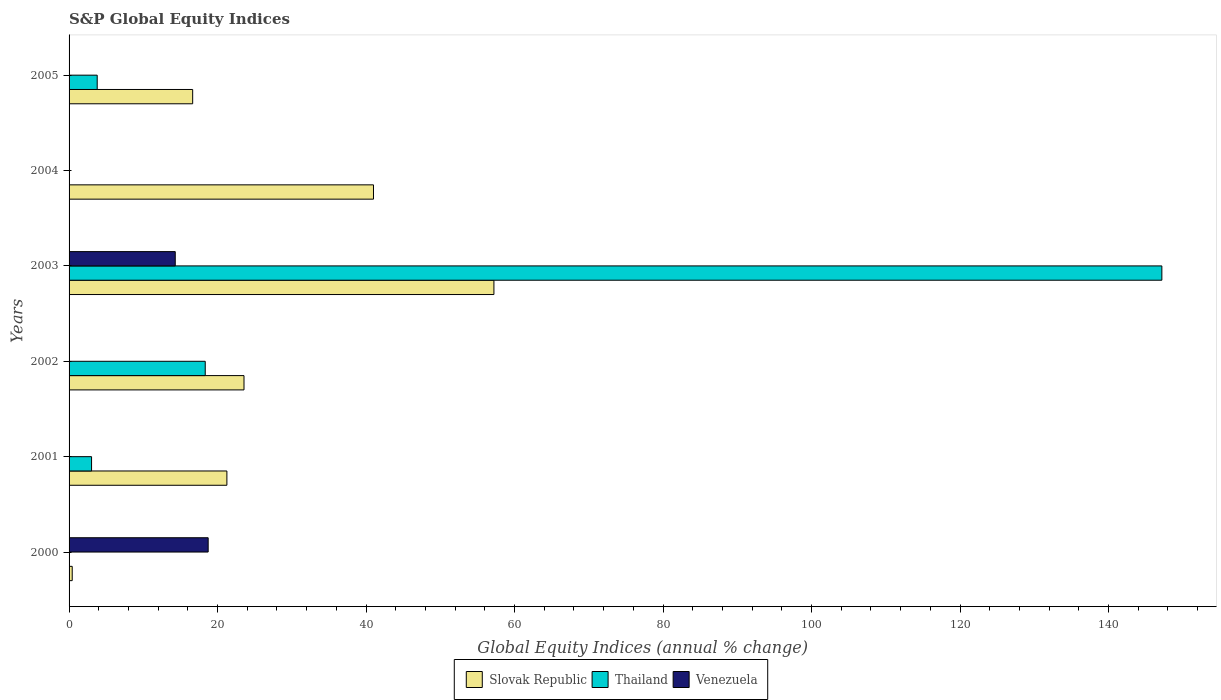How many different coloured bars are there?
Provide a short and direct response. 3. How many bars are there on the 1st tick from the top?
Offer a terse response. 2. How many bars are there on the 4th tick from the bottom?
Provide a succinct answer. 3. What is the label of the 6th group of bars from the top?
Your answer should be compact. 2000. What is the global equity indices in Thailand in 2000?
Provide a short and direct response. 0. Across all years, what is the maximum global equity indices in Venezuela?
Your answer should be very brief. 18.74. What is the total global equity indices in Slovak Republic in the graph?
Offer a very short reply. 160.11. What is the difference between the global equity indices in Slovak Republic in 2004 and that in 2005?
Give a very brief answer. 24.35. What is the difference between the global equity indices in Venezuela in 2003 and the global equity indices in Slovak Republic in 2002?
Your response must be concise. -9.26. What is the average global equity indices in Thailand per year?
Make the answer very short. 28.72. In the year 2000, what is the difference between the global equity indices in Venezuela and global equity indices in Slovak Republic?
Your answer should be compact. 18.31. In how many years, is the global equity indices in Slovak Republic greater than 120 %?
Ensure brevity in your answer.  0. What is the difference between the highest and the second highest global equity indices in Slovak Republic?
Provide a succinct answer. 16.22. What is the difference between the highest and the lowest global equity indices in Thailand?
Keep it short and to the point. 147.18. In how many years, is the global equity indices in Venezuela greater than the average global equity indices in Venezuela taken over all years?
Offer a terse response. 2. How many bars are there?
Offer a terse response. 12. Are all the bars in the graph horizontal?
Your answer should be very brief. Yes. How many years are there in the graph?
Your response must be concise. 6. What is the difference between two consecutive major ticks on the X-axis?
Your response must be concise. 20. Does the graph contain any zero values?
Offer a very short reply. Yes. Where does the legend appear in the graph?
Your answer should be very brief. Bottom center. How are the legend labels stacked?
Keep it short and to the point. Horizontal. What is the title of the graph?
Offer a terse response. S&P Global Equity Indices. What is the label or title of the X-axis?
Offer a terse response. Global Equity Indices (annual % change). What is the label or title of the Y-axis?
Offer a terse response. Years. What is the Global Equity Indices (annual % change) in Slovak Republic in 2000?
Make the answer very short. 0.42. What is the Global Equity Indices (annual % change) of Thailand in 2000?
Offer a very short reply. 0. What is the Global Equity Indices (annual % change) of Venezuela in 2000?
Your answer should be very brief. 18.74. What is the Global Equity Indices (annual % change) of Slovak Republic in 2001?
Offer a very short reply. 21.26. What is the Global Equity Indices (annual % change) in Thailand in 2001?
Make the answer very short. 3.03. What is the Global Equity Indices (annual % change) of Venezuela in 2001?
Offer a terse response. 0. What is the Global Equity Indices (annual % change) of Slovak Republic in 2002?
Make the answer very short. 23.56. What is the Global Equity Indices (annual % change) of Thailand in 2002?
Your answer should be very brief. 18.34. What is the Global Equity Indices (annual % change) in Slovak Republic in 2003?
Offer a terse response. 57.22. What is the Global Equity Indices (annual % change) in Thailand in 2003?
Your answer should be very brief. 147.18. What is the Global Equity Indices (annual % change) of Venezuela in 2003?
Ensure brevity in your answer.  14.3. What is the Global Equity Indices (annual % change) in Slovak Republic in 2004?
Offer a very short reply. 41. What is the Global Equity Indices (annual % change) in Thailand in 2004?
Give a very brief answer. 0. What is the Global Equity Indices (annual % change) in Slovak Republic in 2005?
Your response must be concise. 16.65. What is the Global Equity Indices (annual % change) in Thailand in 2005?
Your response must be concise. 3.79. Across all years, what is the maximum Global Equity Indices (annual % change) in Slovak Republic?
Keep it short and to the point. 57.22. Across all years, what is the maximum Global Equity Indices (annual % change) of Thailand?
Make the answer very short. 147.18. Across all years, what is the maximum Global Equity Indices (annual % change) in Venezuela?
Your answer should be very brief. 18.74. Across all years, what is the minimum Global Equity Indices (annual % change) of Slovak Republic?
Provide a succinct answer. 0.42. Across all years, what is the minimum Global Equity Indices (annual % change) in Venezuela?
Keep it short and to the point. 0. What is the total Global Equity Indices (annual % change) of Slovak Republic in the graph?
Your response must be concise. 160.11. What is the total Global Equity Indices (annual % change) of Thailand in the graph?
Ensure brevity in your answer.  172.34. What is the total Global Equity Indices (annual % change) in Venezuela in the graph?
Provide a short and direct response. 33.04. What is the difference between the Global Equity Indices (annual % change) in Slovak Republic in 2000 and that in 2001?
Give a very brief answer. -20.83. What is the difference between the Global Equity Indices (annual % change) in Slovak Republic in 2000 and that in 2002?
Ensure brevity in your answer.  -23.14. What is the difference between the Global Equity Indices (annual % change) in Slovak Republic in 2000 and that in 2003?
Your response must be concise. -56.8. What is the difference between the Global Equity Indices (annual % change) of Venezuela in 2000 and that in 2003?
Keep it short and to the point. 4.44. What is the difference between the Global Equity Indices (annual % change) in Slovak Republic in 2000 and that in 2004?
Make the answer very short. -40.58. What is the difference between the Global Equity Indices (annual % change) in Slovak Republic in 2000 and that in 2005?
Make the answer very short. -16.22. What is the difference between the Global Equity Indices (annual % change) of Slovak Republic in 2001 and that in 2002?
Your answer should be very brief. -2.3. What is the difference between the Global Equity Indices (annual % change) in Thailand in 2001 and that in 2002?
Your response must be concise. -15.31. What is the difference between the Global Equity Indices (annual % change) of Slovak Republic in 2001 and that in 2003?
Provide a succinct answer. -35.96. What is the difference between the Global Equity Indices (annual % change) in Thailand in 2001 and that in 2003?
Provide a short and direct response. -144.15. What is the difference between the Global Equity Indices (annual % change) of Slovak Republic in 2001 and that in 2004?
Your answer should be very brief. -19.74. What is the difference between the Global Equity Indices (annual % change) in Slovak Republic in 2001 and that in 2005?
Offer a terse response. 4.61. What is the difference between the Global Equity Indices (annual % change) of Thailand in 2001 and that in 2005?
Make the answer very short. -0.76. What is the difference between the Global Equity Indices (annual % change) in Slovak Republic in 2002 and that in 2003?
Offer a very short reply. -33.66. What is the difference between the Global Equity Indices (annual % change) of Thailand in 2002 and that in 2003?
Give a very brief answer. -128.84. What is the difference between the Global Equity Indices (annual % change) of Slovak Republic in 2002 and that in 2004?
Give a very brief answer. -17.44. What is the difference between the Global Equity Indices (annual % change) in Slovak Republic in 2002 and that in 2005?
Give a very brief answer. 6.91. What is the difference between the Global Equity Indices (annual % change) in Thailand in 2002 and that in 2005?
Your answer should be compact. 14.55. What is the difference between the Global Equity Indices (annual % change) in Slovak Republic in 2003 and that in 2004?
Ensure brevity in your answer.  16.22. What is the difference between the Global Equity Indices (annual % change) of Slovak Republic in 2003 and that in 2005?
Make the answer very short. 40.57. What is the difference between the Global Equity Indices (annual % change) of Thailand in 2003 and that in 2005?
Provide a short and direct response. 143.39. What is the difference between the Global Equity Indices (annual % change) of Slovak Republic in 2004 and that in 2005?
Give a very brief answer. 24.35. What is the difference between the Global Equity Indices (annual % change) of Slovak Republic in 2000 and the Global Equity Indices (annual % change) of Thailand in 2001?
Offer a very short reply. -2.61. What is the difference between the Global Equity Indices (annual % change) in Slovak Republic in 2000 and the Global Equity Indices (annual % change) in Thailand in 2002?
Provide a succinct answer. -17.92. What is the difference between the Global Equity Indices (annual % change) in Slovak Republic in 2000 and the Global Equity Indices (annual % change) in Thailand in 2003?
Provide a short and direct response. -146.76. What is the difference between the Global Equity Indices (annual % change) in Slovak Republic in 2000 and the Global Equity Indices (annual % change) in Venezuela in 2003?
Make the answer very short. -13.88. What is the difference between the Global Equity Indices (annual % change) in Slovak Republic in 2000 and the Global Equity Indices (annual % change) in Thailand in 2005?
Make the answer very short. -3.37. What is the difference between the Global Equity Indices (annual % change) in Slovak Republic in 2001 and the Global Equity Indices (annual % change) in Thailand in 2002?
Keep it short and to the point. 2.92. What is the difference between the Global Equity Indices (annual % change) of Slovak Republic in 2001 and the Global Equity Indices (annual % change) of Thailand in 2003?
Make the answer very short. -125.92. What is the difference between the Global Equity Indices (annual % change) of Slovak Republic in 2001 and the Global Equity Indices (annual % change) of Venezuela in 2003?
Provide a short and direct response. 6.96. What is the difference between the Global Equity Indices (annual % change) in Thailand in 2001 and the Global Equity Indices (annual % change) in Venezuela in 2003?
Provide a short and direct response. -11.27. What is the difference between the Global Equity Indices (annual % change) of Slovak Republic in 2001 and the Global Equity Indices (annual % change) of Thailand in 2005?
Provide a short and direct response. 17.47. What is the difference between the Global Equity Indices (annual % change) in Slovak Republic in 2002 and the Global Equity Indices (annual % change) in Thailand in 2003?
Your answer should be compact. -123.62. What is the difference between the Global Equity Indices (annual % change) of Slovak Republic in 2002 and the Global Equity Indices (annual % change) of Venezuela in 2003?
Ensure brevity in your answer.  9.26. What is the difference between the Global Equity Indices (annual % change) in Thailand in 2002 and the Global Equity Indices (annual % change) in Venezuela in 2003?
Your response must be concise. 4.04. What is the difference between the Global Equity Indices (annual % change) in Slovak Republic in 2002 and the Global Equity Indices (annual % change) in Thailand in 2005?
Make the answer very short. 19.77. What is the difference between the Global Equity Indices (annual % change) of Slovak Republic in 2003 and the Global Equity Indices (annual % change) of Thailand in 2005?
Offer a very short reply. 53.43. What is the difference between the Global Equity Indices (annual % change) in Slovak Republic in 2004 and the Global Equity Indices (annual % change) in Thailand in 2005?
Offer a terse response. 37.21. What is the average Global Equity Indices (annual % change) in Slovak Republic per year?
Make the answer very short. 26.68. What is the average Global Equity Indices (annual % change) of Thailand per year?
Your answer should be very brief. 28.72. What is the average Global Equity Indices (annual % change) of Venezuela per year?
Make the answer very short. 5.51. In the year 2000, what is the difference between the Global Equity Indices (annual % change) in Slovak Republic and Global Equity Indices (annual % change) in Venezuela?
Your response must be concise. -18.31. In the year 2001, what is the difference between the Global Equity Indices (annual % change) of Slovak Republic and Global Equity Indices (annual % change) of Thailand?
Give a very brief answer. 18.23. In the year 2002, what is the difference between the Global Equity Indices (annual % change) of Slovak Republic and Global Equity Indices (annual % change) of Thailand?
Your answer should be compact. 5.22. In the year 2003, what is the difference between the Global Equity Indices (annual % change) of Slovak Republic and Global Equity Indices (annual % change) of Thailand?
Ensure brevity in your answer.  -89.96. In the year 2003, what is the difference between the Global Equity Indices (annual % change) in Slovak Republic and Global Equity Indices (annual % change) in Venezuela?
Your answer should be compact. 42.92. In the year 2003, what is the difference between the Global Equity Indices (annual % change) in Thailand and Global Equity Indices (annual % change) in Venezuela?
Offer a terse response. 132.88. In the year 2005, what is the difference between the Global Equity Indices (annual % change) of Slovak Republic and Global Equity Indices (annual % change) of Thailand?
Your response must be concise. 12.86. What is the ratio of the Global Equity Indices (annual % change) of Slovak Republic in 2000 to that in 2001?
Offer a terse response. 0.02. What is the ratio of the Global Equity Indices (annual % change) of Slovak Republic in 2000 to that in 2002?
Ensure brevity in your answer.  0.02. What is the ratio of the Global Equity Indices (annual % change) in Slovak Republic in 2000 to that in 2003?
Offer a terse response. 0.01. What is the ratio of the Global Equity Indices (annual % change) in Venezuela in 2000 to that in 2003?
Your answer should be compact. 1.31. What is the ratio of the Global Equity Indices (annual % change) of Slovak Republic in 2000 to that in 2004?
Make the answer very short. 0.01. What is the ratio of the Global Equity Indices (annual % change) in Slovak Republic in 2000 to that in 2005?
Ensure brevity in your answer.  0.03. What is the ratio of the Global Equity Indices (annual % change) of Slovak Republic in 2001 to that in 2002?
Ensure brevity in your answer.  0.9. What is the ratio of the Global Equity Indices (annual % change) in Thailand in 2001 to that in 2002?
Your response must be concise. 0.17. What is the ratio of the Global Equity Indices (annual % change) in Slovak Republic in 2001 to that in 2003?
Provide a short and direct response. 0.37. What is the ratio of the Global Equity Indices (annual % change) in Thailand in 2001 to that in 2003?
Provide a short and direct response. 0.02. What is the ratio of the Global Equity Indices (annual % change) in Slovak Republic in 2001 to that in 2004?
Your answer should be very brief. 0.52. What is the ratio of the Global Equity Indices (annual % change) in Slovak Republic in 2001 to that in 2005?
Provide a short and direct response. 1.28. What is the ratio of the Global Equity Indices (annual % change) of Thailand in 2001 to that in 2005?
Your response must be concise. 0.8. What is the ratio of the Global Equity Indices (annual % change) in Slovak Republic in 2002 to that in 2003?
Keep it short and to the point. 0.41. What is the ratio of the Global Equity Indices (annual % change) in Thailand in 2002 to that in 2003?
Your answer should be very brief. 0.12. What is the ratio of the Global Equity Indices (annual % change) in Slovak Republic in 2002 to that in 2004?
Give a very brief answer. 0.57. What is the ratio of the Global Equity Indices (annual % change) of Slovak Republic in 2002 to that in 2005?
Your answer should be very brief. 1.42. What is the ratio of the Global Equity Indices (annual % change) of Thailand in 2002 to that in 2005?
Provide a succinct answer. 4.84. What is the ratio of the Global Equity Indices (annual % change) in Slovak Republic in 2003 to that in 2004?
Provide a short and direct response. 1.4. What is the ratio of the Global Equity Indices (annual % change) of Slovak Republic in 2003 to that in 2005?
Ensure brevity in your answer.  3.44. What is the ratio of the Global Equity Indices (annual % change) in Thailand in 2003 to that in 2005?
Offer a terse response. 38.84. What is the ratio of the Global Equity Indices (annual % change) in Slovak Republic in 2004 to that in 2005?
Give a very brief answer. 2.46. What is the difference between the highest and the second highest Global Equity Indices (annual % change) of Slovak Republic?
Give a very brief answer. 16.22. What is the difference between the highest and the second highest Global Equity Indices (annual % change) in Thailand?
Your response must be concise. 128.84. What is the difference between the highest and the lowest Global Equity Indices (annual % change) in Slovak Republic?
Your answer should be very brief. 56.8. What is the difference between the highest and the lowest Global Equity Indices (annual % change) of Thailand?
Offer a terse response. 147.18. What is the difference between the highest and the lowest Global Equity Indices (annual % change) in Venezuela?
Ensure brevity in your answer.  18.74. 